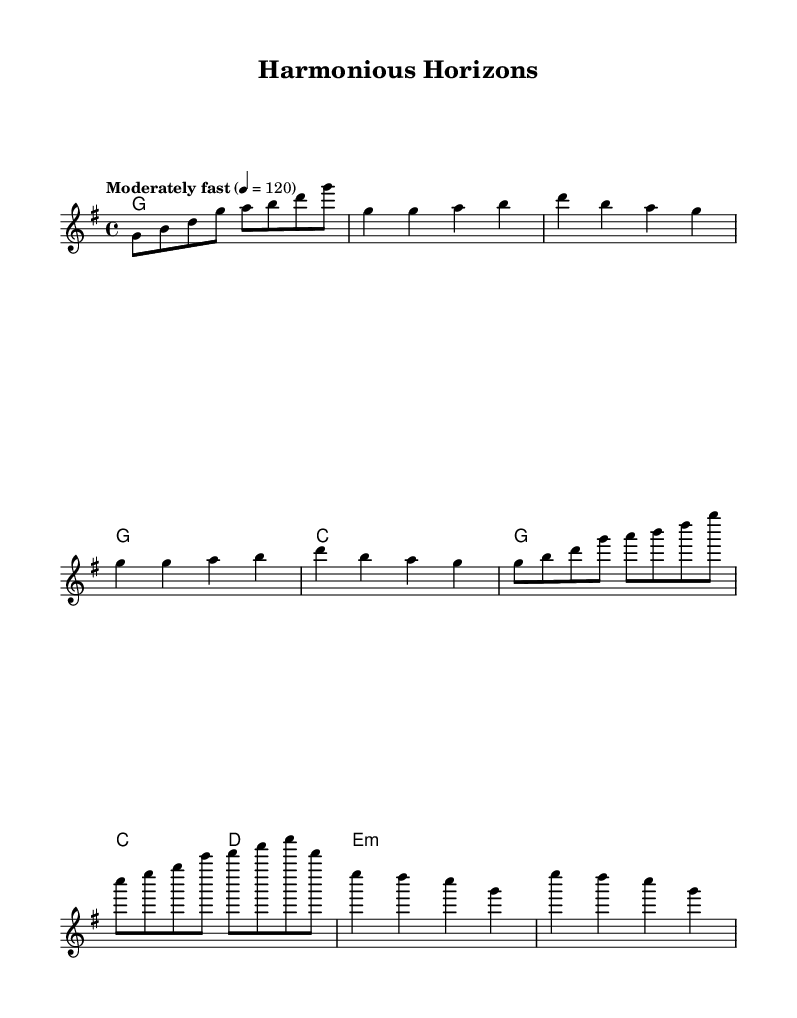What is the key signature of this music? The key signature indicates G major, which features one sharp (F#) and implies that the piece is centered around the G major scale.
Answer: G major What is the time signature of this music? The time signature is 4/4, meaning there are four beats in each measure and the quarter note gets one beat.
Answer: 4/4 What is the tempo marking for this music? The tempo marking states "Moderately fast," with a specific goal of 120 beats per minute, suggesting a lively pace.
Answer: Moderately fast How many measures does the intro of the piece have? The intro consists of four measures, as indicated by the grouping of notes prior to the first verse.
Answer: 4 What chords are used in the verse? The chords in the verse are G, C, and G, which establish a basic harmonic framework characteristic of blues music.
Answer: G, C, G Identify a musical feature that is characteristic of blues in this piece. The use of a call-and-response pattern can be identified in the melody, a traditional feature of blues that fosters interaction between musical phrases.
Answer: Call-and-response What is the last chord of the bridge section? The last chord in the bridge section is E minor, which provides a transition back to the primary themes of the piece characteristic of blues progressions.
Answer: E minor 